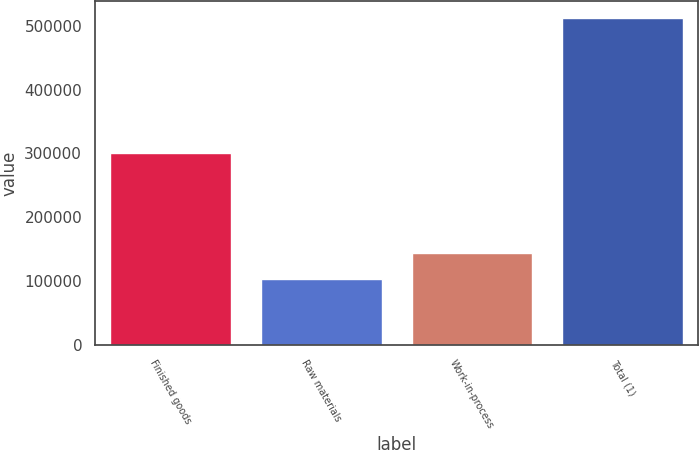Convert chart. <chart><loc_0><loc_0><loc_500><loc_500><bar_chart><fcel>Finished goods<fcel>Raw materials<fcel>Work-in-process<fcel>Total (1)<nl><fcel>299975<fcel>102563<fcel>143577<fcel>512707<nl></chart> 